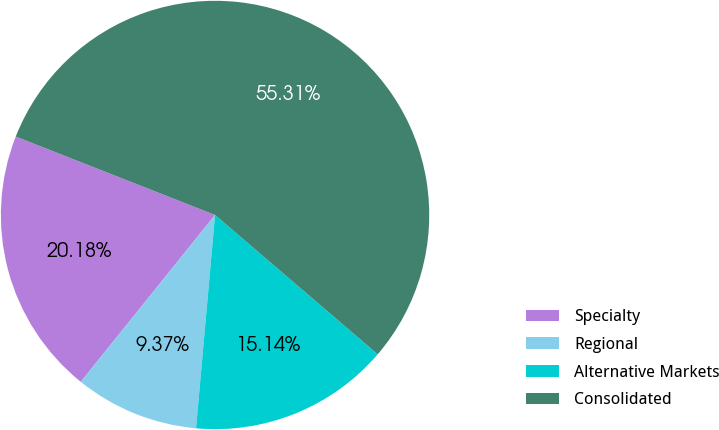<chart> <loc_0><loc_0><loc_500><loc_500><pie_chart><fcel>Specialty<fcel>Regional<fcel>Alternative Markets<fcel>Consolidated<nl><fcel>20.18%<fcel>9.37%<fcel>15.14%<fcel>55.31%<nl></chart> 